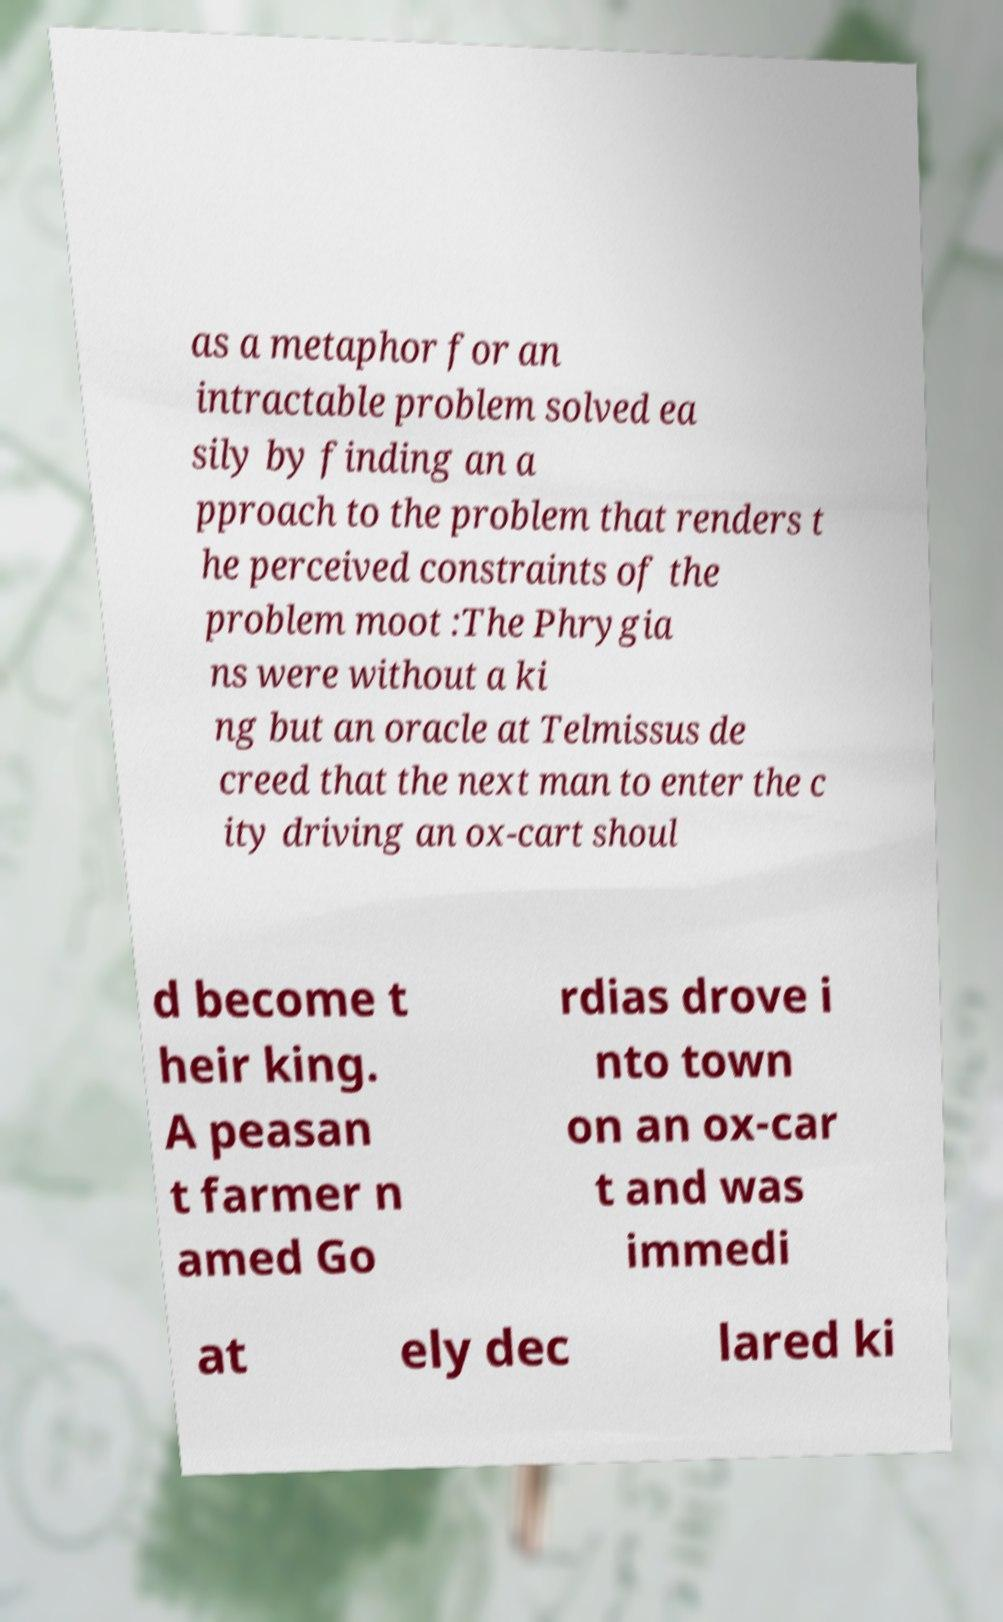Can you read and provide the text displayed in the image?This photo seems to have some interesting text. Can you extract and type it out for me? as a metaphor for an intractable problem solved ea sily by finding an a pproach to the problem that renders t he perceived constraints of the problem moot :The Phrygia ns were without a ki ng but an oracle at Telmissus de creed that the next man to enter the c ity driving an ox-cart shoul d become t heir king. A peasan t farmer n amed Go rdias drove i nto town on an ox-car t and was immedi at ely dec lared ki 